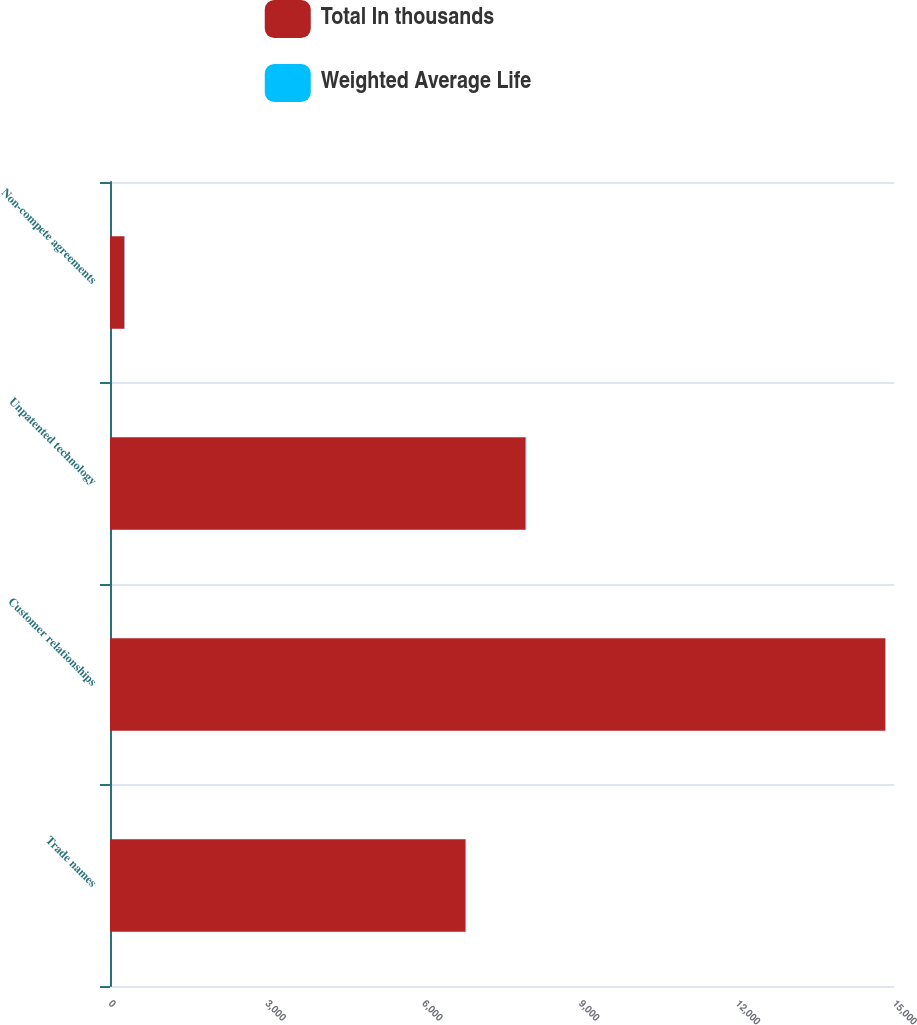<chart> <loc_0><loc_0><loc_500><loc_500><stacked_bar_chart><ecel><fcel>Trade names<fcel>Customer relationships<fcel>Unpatented technology<fcel>Non-compete agreements<nl><fcel>Total In thousands<fcel>6802<fcel>14832<fcel>7951<fcel>276<nl><fcel>Weighted Average Life<fcel>13<fcel>8<fcel>14<fcel>3<nl></chart> 